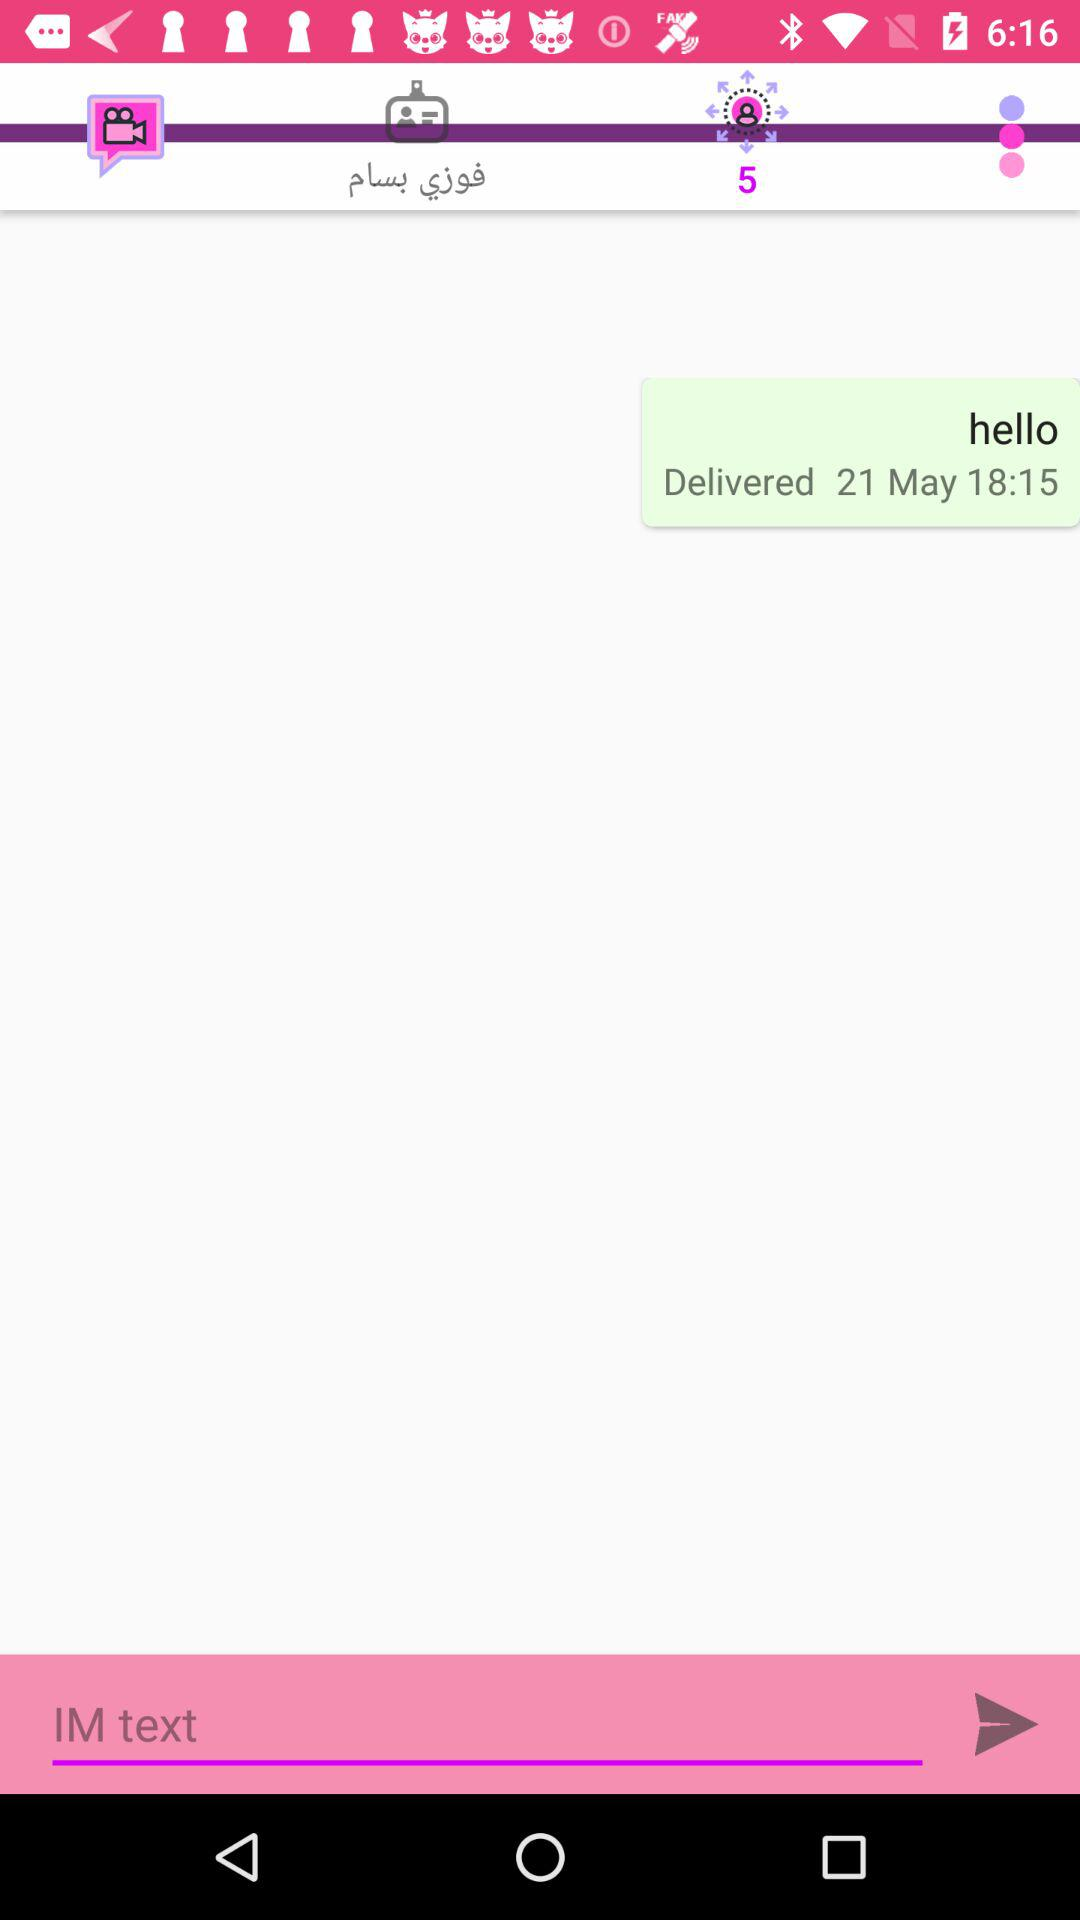What is the message's delivery time? The message's delivery time is 18:15. 